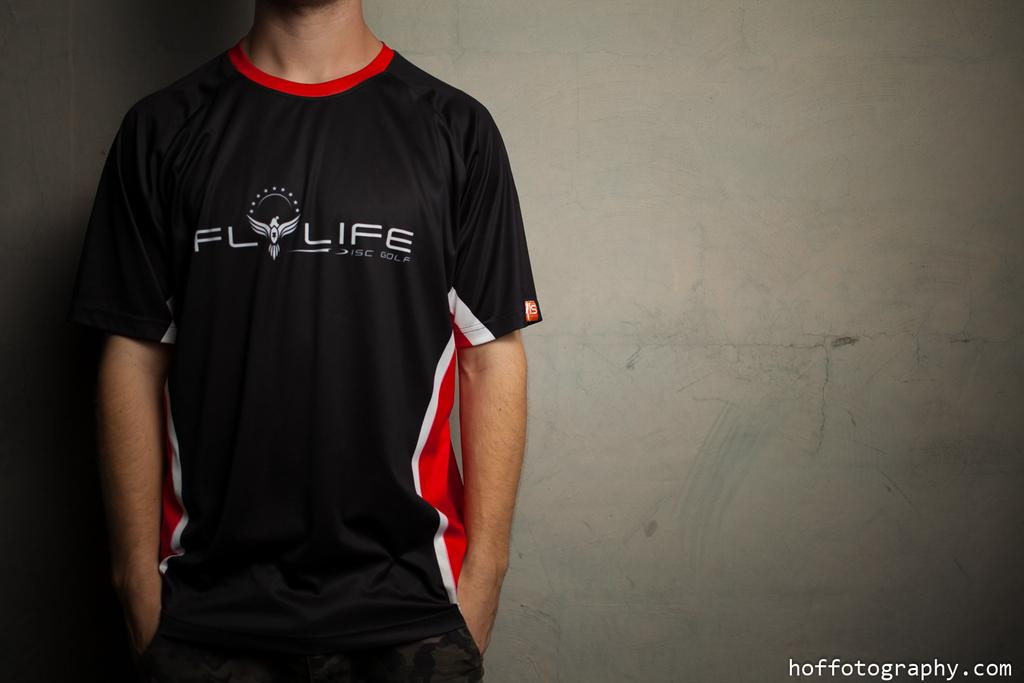<image>
Give a short and clear explanation of the subsequent image. A man wearing a FlOLIFE shirt stands against a grey background 